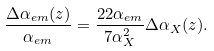<formula> <loc_0><loc_0><loc_500><loc_500>\frac { \Delta \alpha _ { e m } ( z ) } { \alpha _ { e m } } = \frac { 2 2 \alpha _ { e m } } { 7 \alpha ^ { 2 } _ { X } } \Delta \alpha _ { X } ( z ) .</formula> 